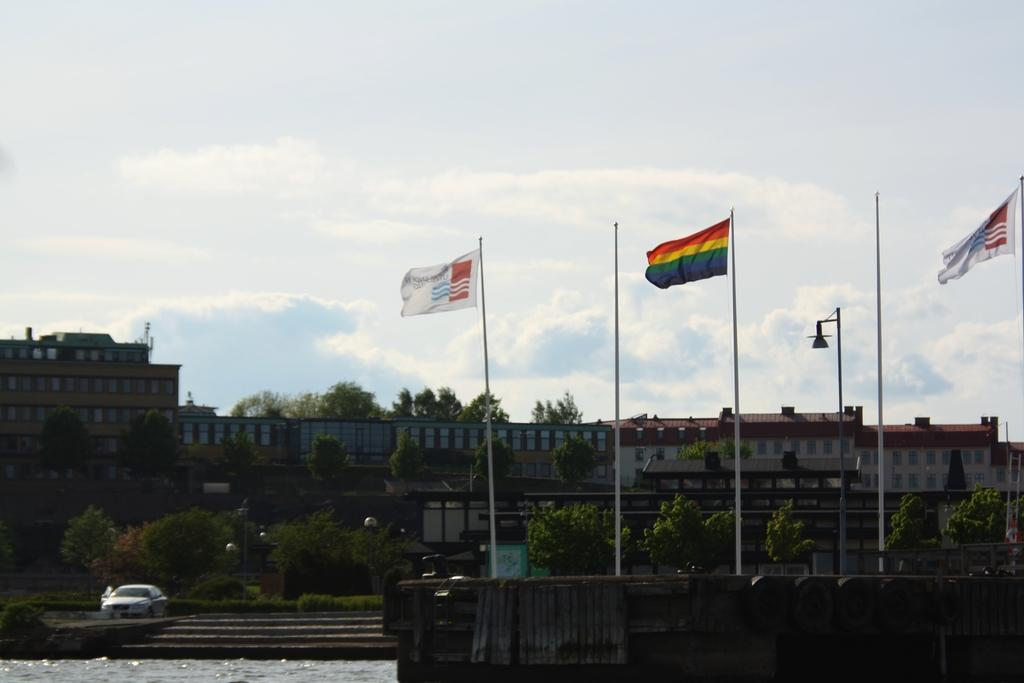What structures are present in the image? There are poles, flags, water, plants, trees, buildings, and a car visible in the image. What can be seen flying in the image? Flags are flying in the image. What type of natural elements are present in the image? There are plants, trees, water, and clouds visible in the image. What is the background of the image? The sky is visible in the background of the image, with clouds present. How many rabbits can be seen hopping around the car in the image? There are no rabbits present in the image; it features poles, flags, water, plants, trees, buildings, and a car. What type of cream is being used to paint the buildings in the image? There is no cream being used to paint the buildings in the image; the buildings are already constructed and visible in the image. 